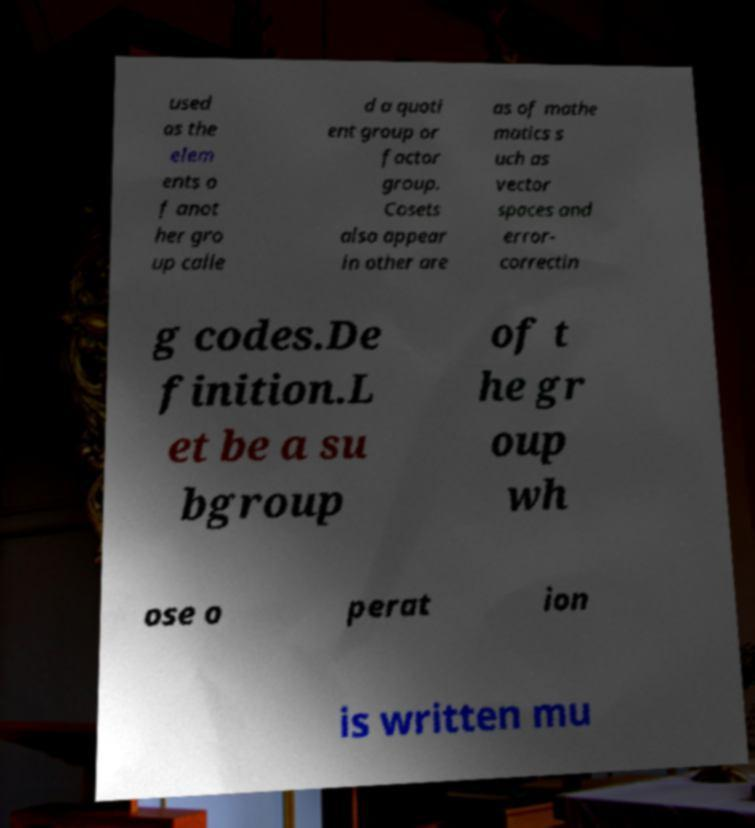Please read and relay the text visible in this image. What does it say? used as the elem ents o f anot her gro up calle d a quoti ent group or factor group. Cosets also appear in other are as of mathe matics s uch as vector spaces and error- correctin g codes.De finition.L et be a su bgroup of t he gr oup wh ose o perat ion is written mu 